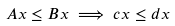Convert formula to latex. <formula><loc_0><loc_0><loc_500><loc_500>A x \leq B x \implies c x \leq d x</formula> 